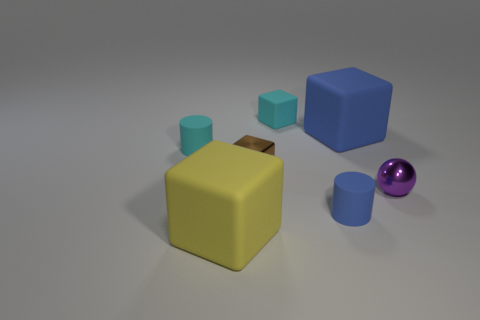Add 2 small blue metallic cylinders. How many objects exist? 9 Subtract all cylinders. How many objects are left? 5 Subtract 0 red blocks. How many objects are left? 7 Subtract all big red matte balls. Subtract all blue objects. How many objects are left? 5 Add 3 blue objects. How many blue objects are left? 5 Add 7 big yellow matte things. How many big yellow matte things exist? 8 